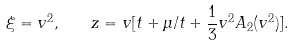<formula> <loc_0><loc_0><loc_500><loc_500>\xi = v ^ { 2 } , \quad z = v [ t + \mu / t + \frac { 1 } { 3 } v ^ { 2 } A _ { 2 } ( v ^ { 2 } ) ] .</formula> 